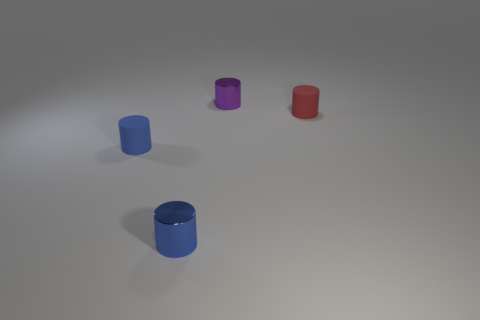What number of tiny purple things have the same shape as the small red thing?
Offer a terse response. 1. Is there a small blue cylinder that has the same material as the small purple object?
Ensure brevity in your answer.  Yes. How many brown things are there?
Your response must be concise. 0. What number of cubes are either tiny purple things or blue shiny things?
Give a very brief answer. 0. What color is the other matte object that is the same size as the red rubber object?
Offer a very short reply. Blue. What number of tiny metallic cylinders are both behind the tiny red object and in front of the tiny red object?
Keep it short and to the point. 0. What material is the red cylinder?
Provide a short and direct response. Rubber. What number of objects are either big gray metal balls or red things?
Offer a very short reply. 1. There is a matte cylinder in front of the small red cylinder; is its size the same as the cylinder behind the red matte object?
Provide a short and direct response. Yes. How many other things are the same size as the red rubber object?
Offer a terse response. 3. 